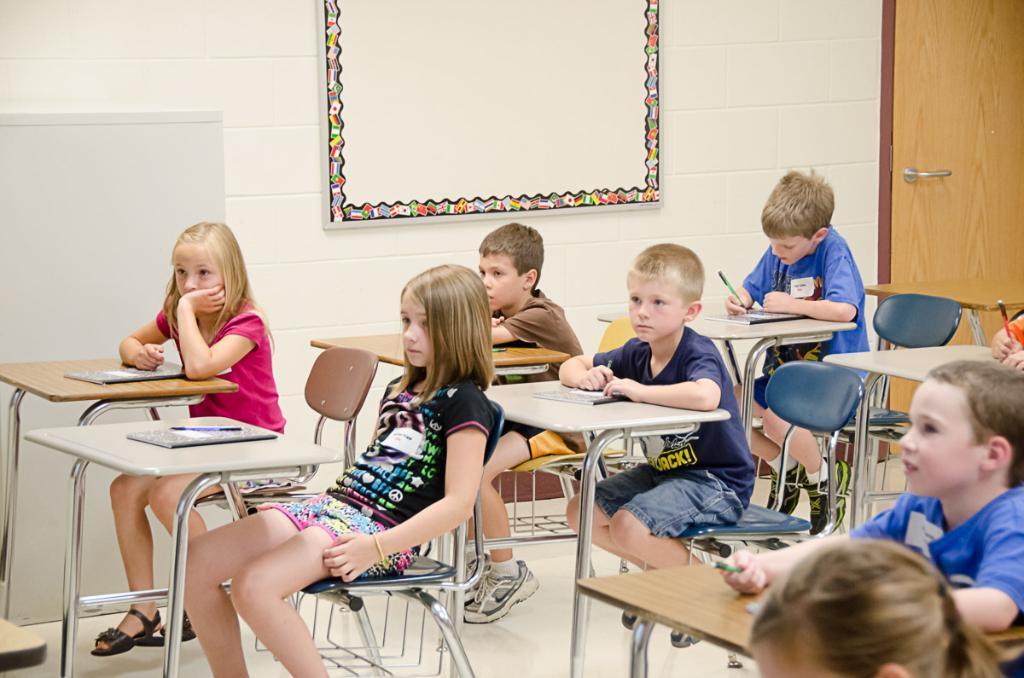How would you summarize this image in a sentence or two? Some children are sitting in a classroom and listening to a teacher. 